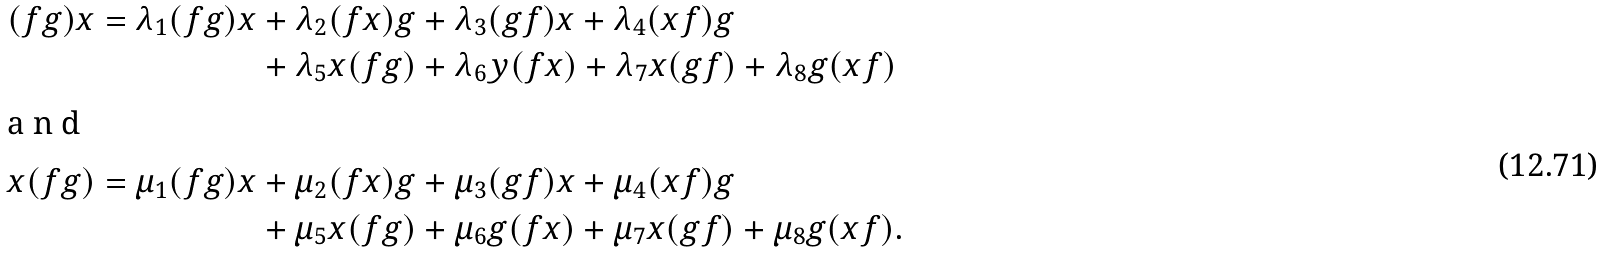<formula> <loc_0><loc_0><loc_500><loc_500>( f g ) x = \lambda _ { 1 } ( f g ) x & + \lambda _ { 2 } ( f x ) g + \lambda _ { 3 } ( g f ) x + \lambda _ { 4 } ( x f ) g \\ & + \lambda _ { 5 } x ( f g ) + \lambda _ { 6 } y ( f x ) + \lambda _ { 7 } x ( g f ) + \lambda _ { 8 } g ( x f ) \\ \intertext { a n d } x ( f g ) = \mu _ { 1 } ( f g ) x & + \mu _ { 2 } ( f x ) g + \mu _ { 3 } ( g f ) x + \mu _ { 4 } ( x f ) g \\ & + \mu _ { 5 } x ( f g ) + \mu _ { 6 } g ( f x ) + \mu _ { 7 } x ( g f ) + \mu _ { 8 } g ( x f ) .</formula> 